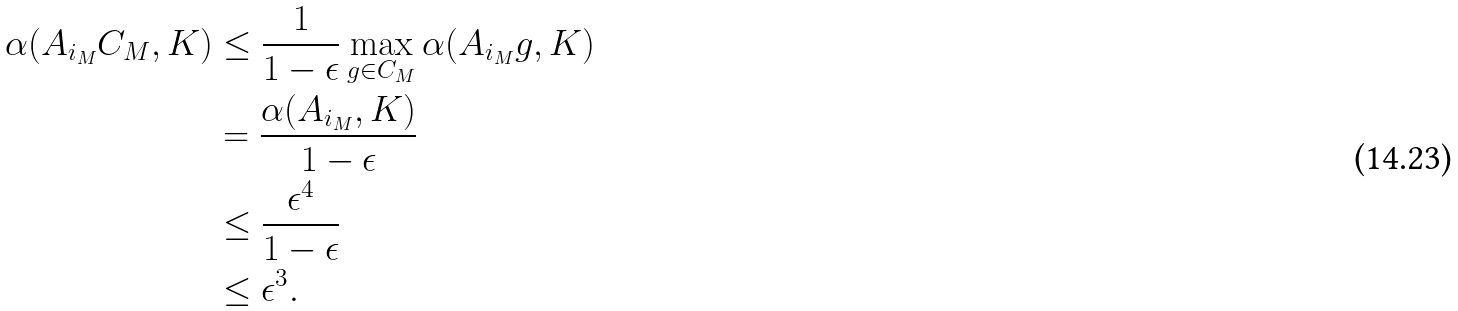<formula> <loc_0><loc_0><loc_500><loc_500>\alpha ( A _ { i _ { M } } C _ { M } , K ) & \leq \frac { 1 } { 1 - \epsilon } \max _ { g \in C _ { M } } \alpha ( A _ { i _ { M } } g , K ) \\ & = \frac { \alpha ( A _ { i _ { M } } , K ) } { 1 - \epsilon } \\ & \leq \frac { \epsilon ^ { 4 } } { 1 - \epsilon } \\ & \leq \epsilon ^ { 3 } .</formula> 